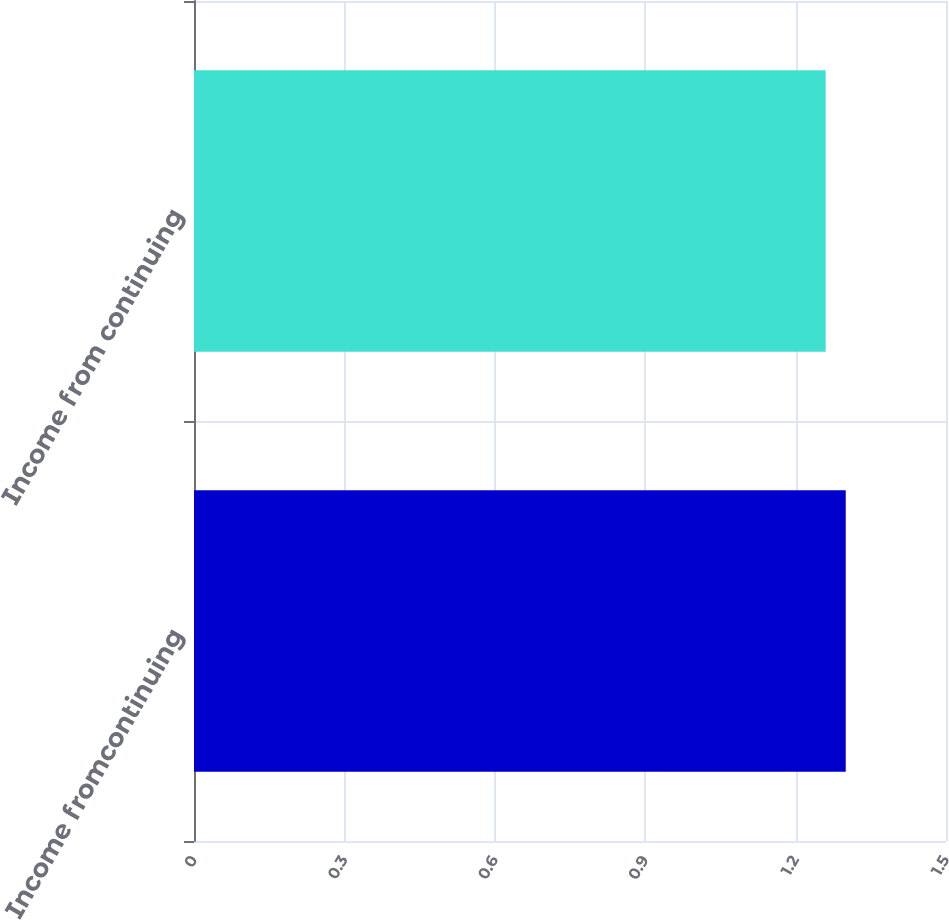Convert chart. <chart><loc_0><loc_0><loc_500><loc_500><bar_chart><fcel>Income fromcontinuing<fcel>Income from continuing<nl><fcel>1.3<fcel>1.26<nl></chart> 